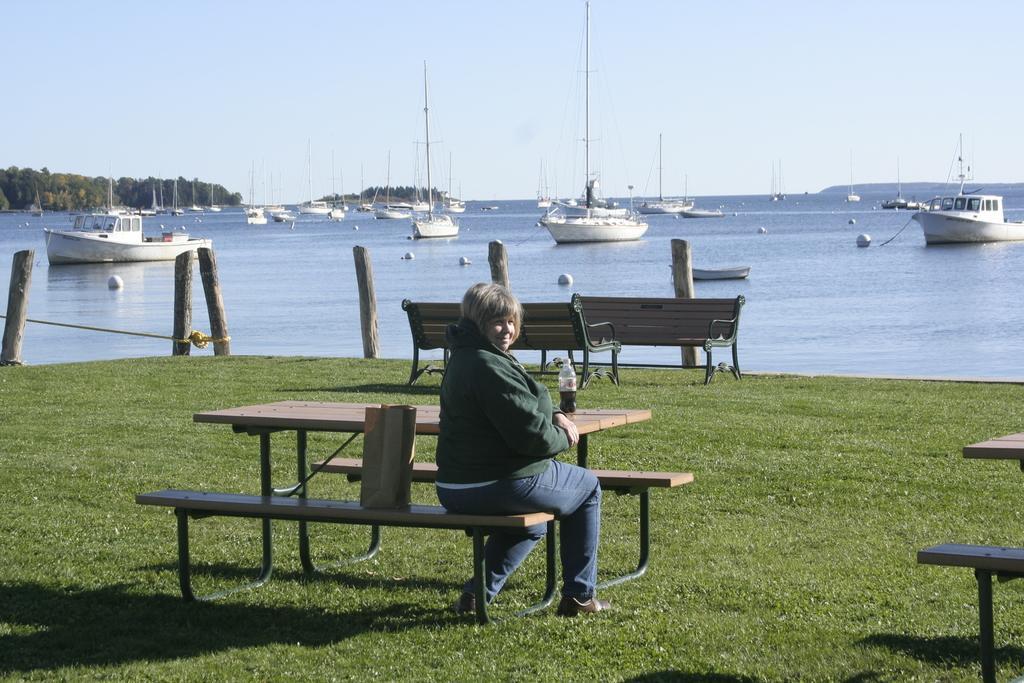Please provide a concise description of this image. In this image there are benches on a grassland and a woman sitting a bench, beside her there is a bag, in front of her there is a table, on that table there is a bottle in the background there are wooden pole and there are boats on the sea and there are trees and the sky. 